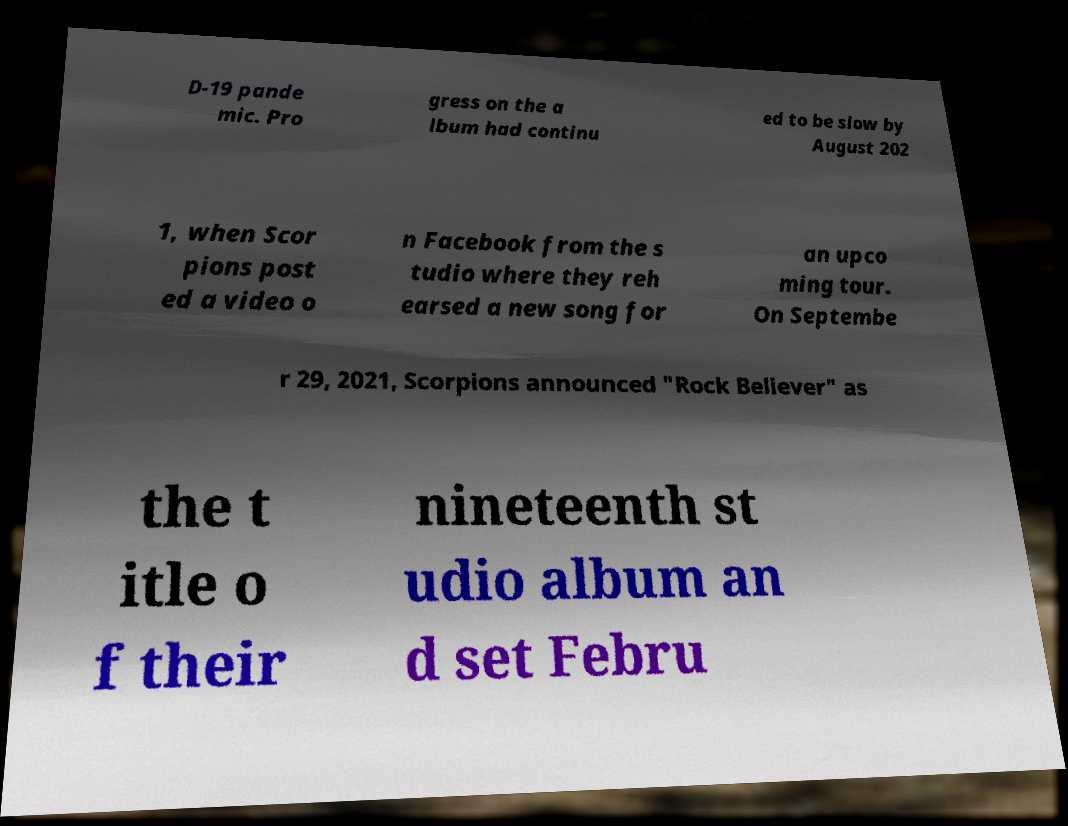Please read and relay the text visible in this image. What does it say? D-19 pande mic. Pro gress on the a lbum had continu ed to be slow by August 202 1, when Scor pions post ed a video o n Facebook from the s tudio where they reh earsed a new song for an upco ming tour. On Septembe r 29, 2021, Scorpions announced "Rock Believer" as the t itle o f their nineteenth st udio album an d set Febru 